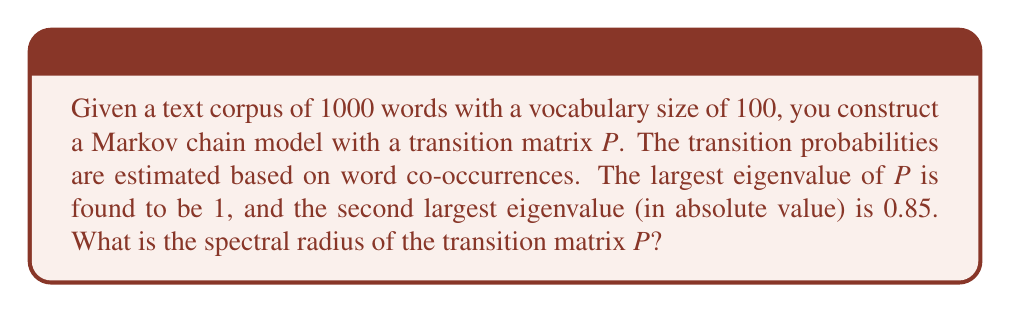What is the answer to this math problem? To solve this problem, let's follow these steps:

1) First, recall that the spectral radius of a matrix is defined as the maximum of the absolute values of its eigenvalues:

   $$\rho(P) = \max_{i} |\lambda_i|$$

   where $\lambda_i$ are the eigenvalues of $P$.

2) For a transition matrix of a Markov chain:
   - It always has 1 as an eigenvalue.
   - All other eigenvalues have absolute value less than or equal to 1.

3) In this case, we're given that:
   - The largest eigenvalue is 1.
   - The second largest eigenvalue (in absolute value) is 0.85.

4) Since 1 is larger than 0.85, and we know 1 is always an eigenvalue of a transition matrix, we can conclude that 1 is the largest eigenvalue in absolute value.

5) Therefore, the spectral radius of $P$ is 1.

This result is consistent with the properties of transition matrices in Markov chains, where the spectral radius is always 1, reflecting the fact that the chain conserves probability mass.
Answer: 1 